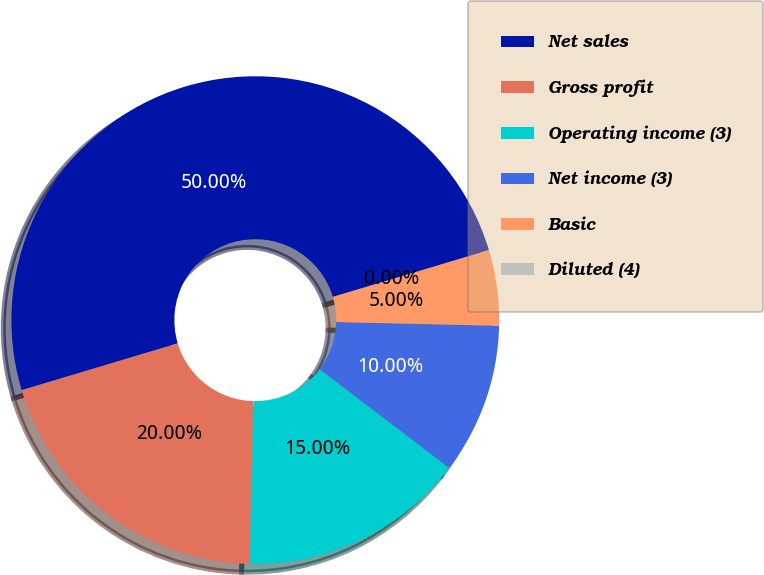<chart> <loc_0><loc_0><loc_500><loc_500><pie_chart><fcel>Net sales<fcel>Gross profit<fcel>Operating income (3)<fcel>Net income (3)<fcel>Basic<fcel>Diluted (4)<nl><fcel>50.0%<fcel>20.0%<fcel>15.0%<fcel>10.0%<fcel>5.0%<fcel>0.0%<nl></chart> 